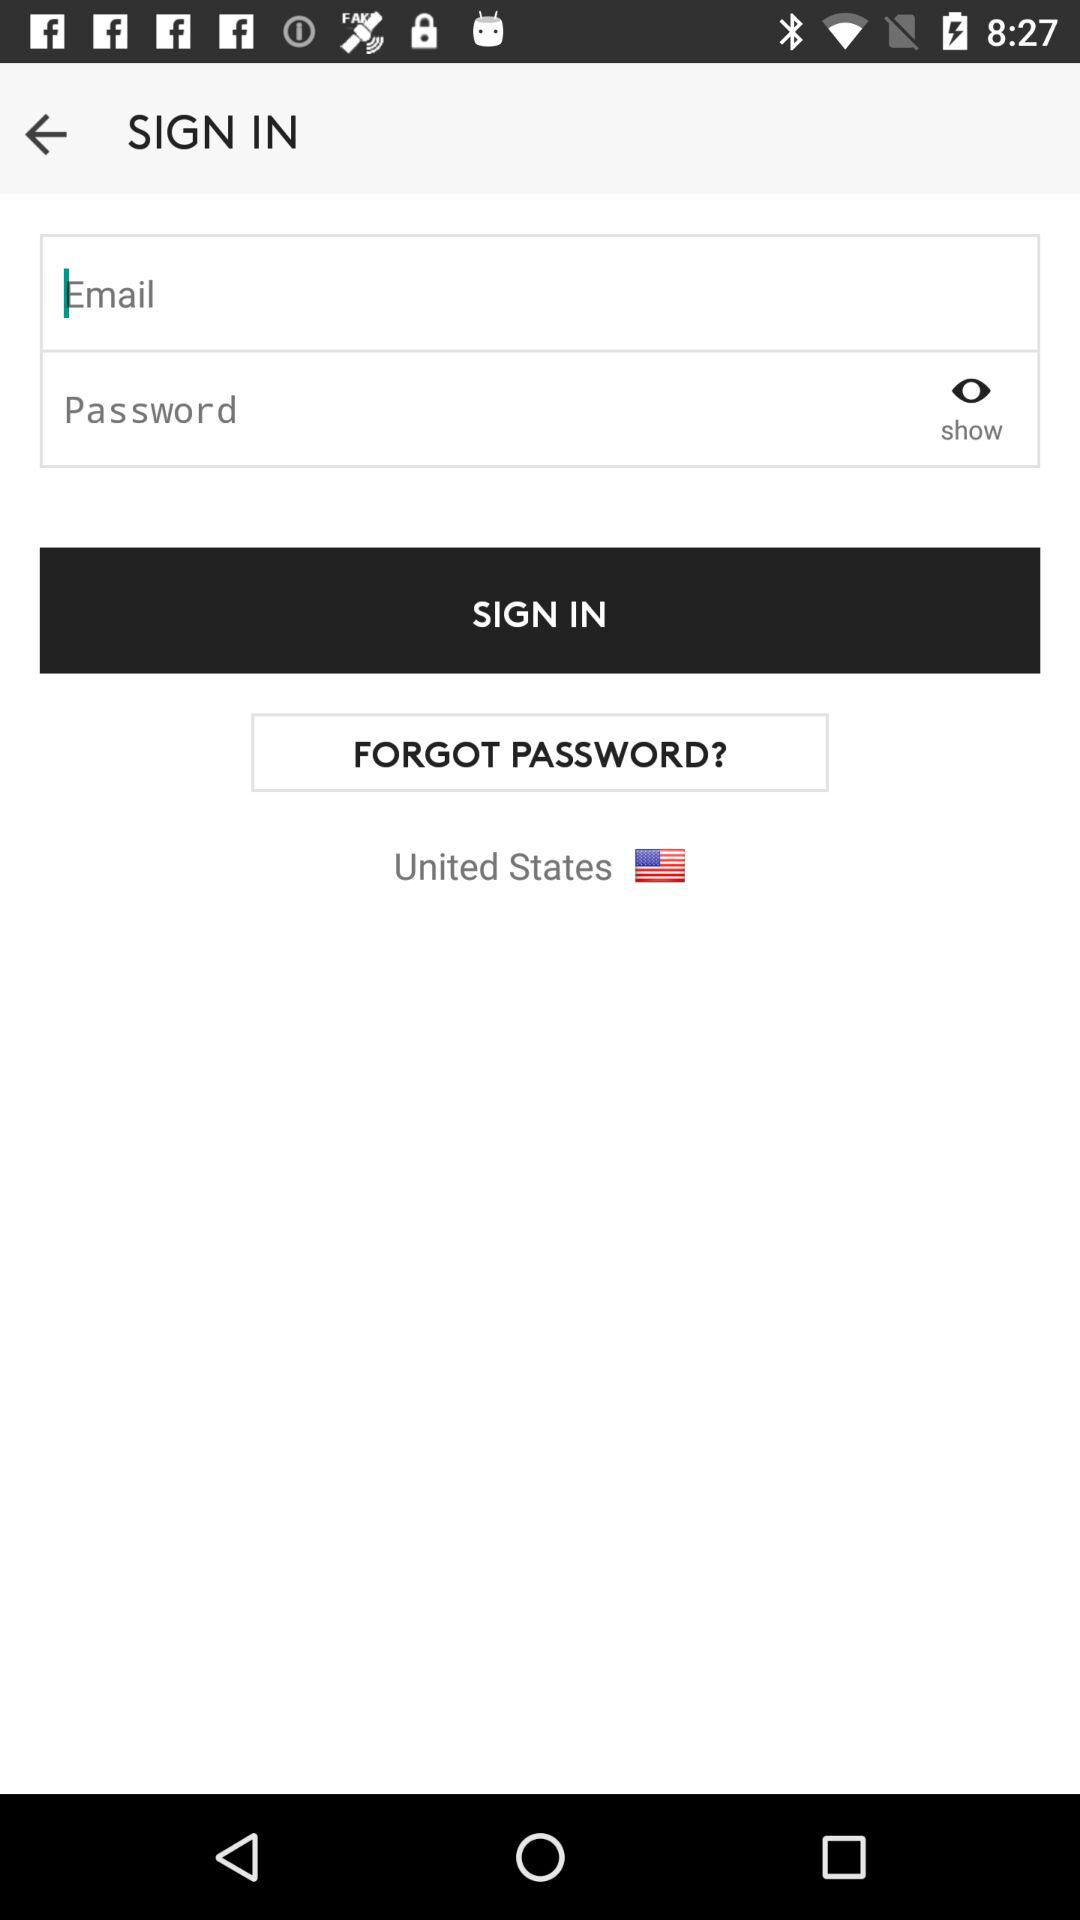What is the current location? The current location is the United States. 